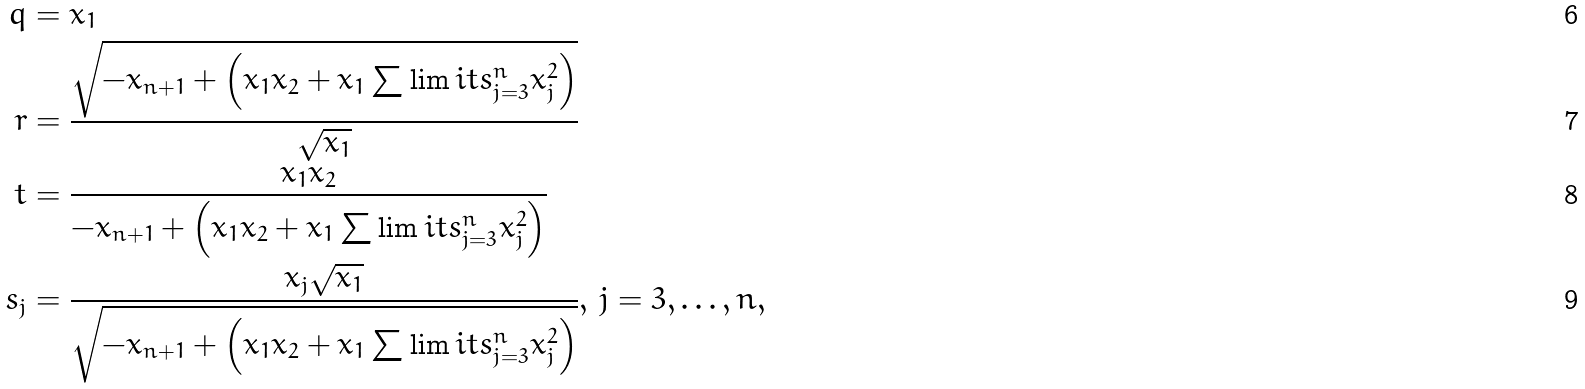Convert formula to latex. <formula><loc_0><loc_0><loc_500><loc_500>q & = x _ { 1 } \\ r & = \frac { \sqrt { - x _ { n + 1 } + \left ( x _ { 1 } x _ { 2 } + x _ { 1 } \sum \lim i t s _ { j = 3 } ^ { n } x _ { j } ^ { 2 } \right ) } } { \sqrt { x _ { 1 } } } \\ t & = \frac { x _ { 1 } x _ { 2 } } { - x _ { n + 1 } + \left ( x _ { 1 } x _ { 2 } + x _ { 1 } \sum \lim i t s _ { j = 3 } ^ { n } x _ { j } ^ { 2 } \right ) } \\ s _ { j } & = \frac { x _ { j } \sqrt { x _ { 1 } } } { \sqrt { - x _ { n + 1 } + \left ( x _ { 1 } x _ { 2 } + x _ { 1 } \sum \lim i t s _ { j = 3 } ^ { n } x _ { j } ^ { 2 } \right ) } } , \, j = 3 , \dots , n ,</formula> 